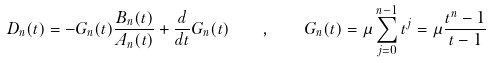<formula> <loc_0><loc_0><loc_500><loc_500>D _ { n } ( t ) = - G _ { n } ( t ) \frac { B _ { n } ( t ) } { A _ { n } ( t ) } + \frac { d } { d t } G _ { n } ( t ) \quad , \quad G _ { n } ( t ) = \mu \sum _ { j = 0 } ^ { n - 1 } t ^ { j } = \mu \frac { t ^ { n } - 1 } { t - 1 }</formula> 